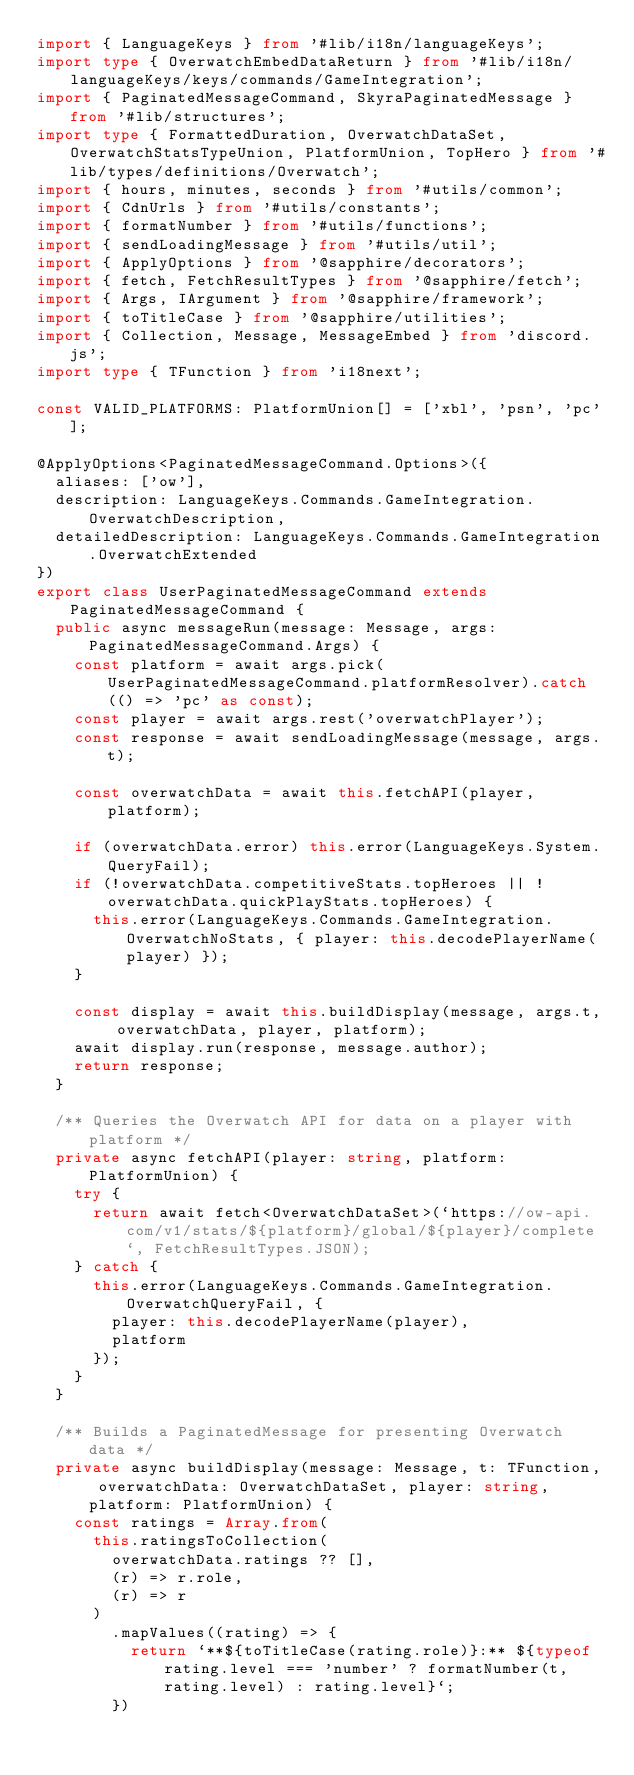<code> <loc_0><loc_0><loc_500><loc_500><_TypeScript_>import { LanguageKeys } from '#lib/i18n/languageKeys';
import type { OverwatchEmbedDataReturn } from '#lib/i18n/languageKeys/keys/commands/GameIntegration';
import { PaginatedMessageCommand, SkyraPaginatedMessage } from '#lib/structures';
import type { FormattedDuration, OverwatchDataSet, OverwatchStatsTypeUnion, PlatformUnion, TopHero } from '#lib/types/definitions/Overwatch';
import { hours, minutes, seconds } from '#utils/common';
import { CdnUrls } from '#utils/constants';
import { formatNumber } from '#utils/functions';
import { sendLoadingMessage } from '#utils/util';
import { ApplyOptions } from '@sapphire/decorators';
import { fetch, FetchResultTypes } from '@sapphire/fetch';
import { Args, IArgument } from '@sapphire/framework';
import { toTitleCase } from '@sapphire/utilities';
import { Collection, Message, MessageEmbed } from 'discord.js';
import type { TFunction } from 'i18next';

const VALID_PLATFORMS: PlatformUnion[] = ['xbl', 'psn', 'pc'];

@ApplyOptions<PaginatedMessageCommand.Options>({
	aliases: ['ow'],
	description: LanguageKeys.Commands.GameIntegration.OverwatchDescription,
	detailedDescription: LanguageKeys.Commands.GameIntegration.OverwatchExtended
})
export class UserPaginatedMessageCommand extends PaginatedMessageCommand {
	public async messageRun(message: Message, args: PaginatedMessageCommand.Args) {
		const platform = await args.pick(UserPaginatedMessageCommand.platformResolver).catch(() => 'pc' as const);
		const player = await args.rest('overwatchPlayer');
		const response = await sendLoadingMessage(message, args.t);

		const overwatchData = await this.fetchAPI(player, platform);

		if (overwatchData.error) this.error(LanguageKeys.System.QueryFail);
		if (!overwatchData.competitiveStats.topHeroes || !overwatchData.quickPlayStats.topHeroes) {
			this.error(LanguageKeys.Commands.GameIntegration.OverwatchNoStats, { player: this.decodePlayerName(player) });
		}

		const display = await this.buildDisplay(message, args.t, overwatchData, player, platform);
		await display.run(response, message.author);
		return response;
	}

	/** Queries the Overwatch API for data on a player with platform */
	private async fetchAPI(player: string, platform: PlatformUnion) {
		try {
			return await fetch<OverwatchDataSet>(`https://ow-api.com/v1/stats/${platform}/global/${player}/complete`, FetchResultTypes.JSON);
		} catch {
			this.error(LanguageKeys.Commands.GameIntegration.OverwatchQueryFail, {
				player: this.decodePlayerName(player),
				platform
			});
		}
	}

	/** Builds a PaginatedMessage for presenting Overwatch data */
	private async buildDisplay(message: Message, t: TFunction, overwatchData: OverwatchDataSet, player: string, platform: PlatformUnion) {
		const ratings = Array.from(
			this.ratingsToCollection(
				overwatchData.ratings ?? [],
				(r) => r.role,
				(r) => r
			)
				.mapValues((rating) => {
					return `**${toTitleCase(rating.role)}:** ${typeof rating.level === 'number' ? formatNumber(t, rating.level) : rating.level}`;
				})</code> 